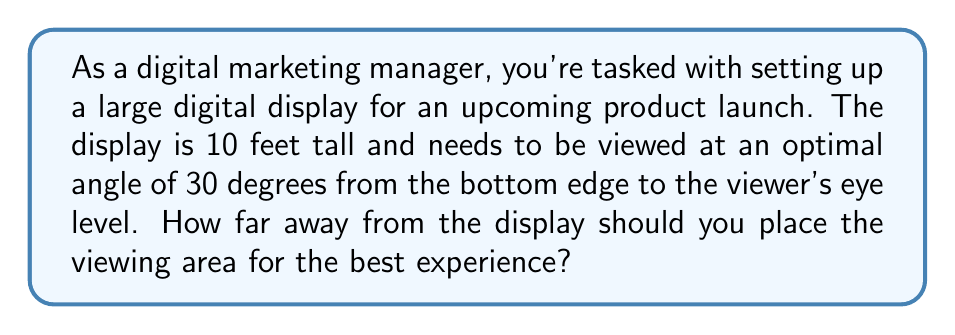Can you solve this math problem? Let's approach this step-by-step using trigonometry:

1) First, we need to visualize the problem. We have a right triangle where:
   - The height of the display (10 feet) is the opposite side
   - The viewing distance we're looking for is the adjacent side
   - The angle from the bottom of the display to the viewer's eye is 30°

2) In this scenario, we're using the tangent ratio. The tangent of an angle in a right triangle is the ratio of the opposite side to the adjacent side.

3) We can express this as an equation:

   $$\tan(30°) = \frac{\text{opposite}}{\text{adjacent}} = \frac{\text{height of display}}{\text{viewing distance}}$$

4) We know the angle (30°) and the height (10 feet). Let's call the viewing distance $x$. So our equation becomes:

   $$\tan(30°) = \frac{10}{x}$$

5) To solve for $x$, we multiply both sides by $x$:

   $$x \cdot \tan(30°) = 10$$

6) Then divide both sides by $\tan(30°)$:

   $$x = \frac{10}{\tan(30°)}$$

7) Now we can calculate. The $\tan(30°)$ is approximately 0.5774. So:

   $$x = \frac{10}{0.5774} \approx 17.32 \text{ feet}$$

This means the optimal viewing distance is about 17.32 feet from the base of the display.
Answer: The optimal viewing distance is approximately 17.32 feet from the base of the digital display. 